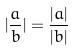Convert formula to latex. <formula><loc_0><loc_0><loc_500><loc_500>| \frac { a } { b } | = \frac { | a | } { | b | }</formula> 